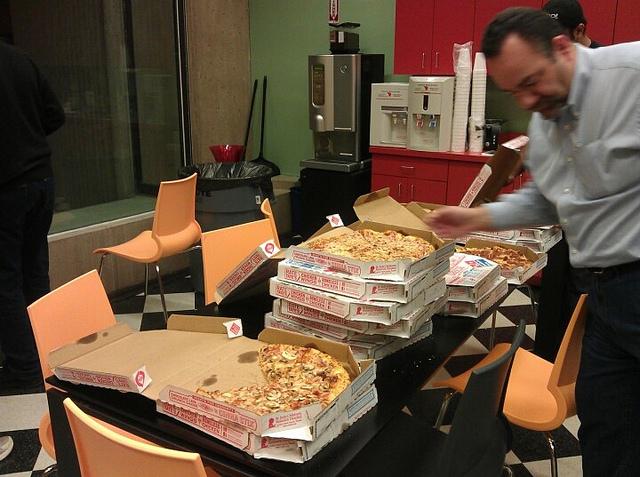How many pizza boxes?
Answer briefly. 11. What restaurant made the pizzas?
Answer briefly. Dominos. What entree is this?
Be succinct. Pizza. Is the man wearing a hat?
Write a very short answer. No. How many slices of pizza are missing?
Keep it brief. 2. Is the food freshly baked?
Short answer required. Yes. Could those be soft pretzels?
Write a very short answer. No. How much coffee is present?
Write a very short answer. 0. What gender of people is doing most of the serving?
Write a very short answer. Male. 